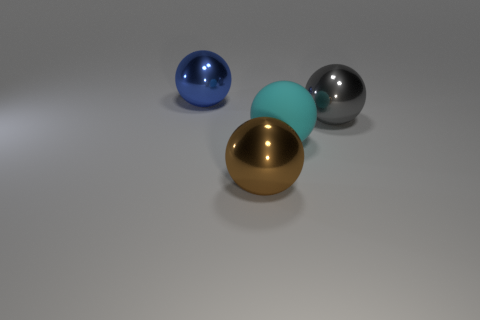What number of things are there?
Your answer should be compact. 4. What is the shape of the metallic object that is to the right of the big shiny sphere that is in front of the large sphere right of the big matte object?
Your response must be concise. Sphere. Are there fewer big gray metallic objects behind the big gray shiny sphere than large rubber things on the left side of the brown metal object?
Offer a very short reply. No. There is a big thing in front of the cyan ball; is its shape the same as the big shiny thing that is on the right side of the matte object?
Ensure brevity in your answer.  Yes. Is there a large purple thing made of the same material as the gray thing?
Make the answer very short. No. What material is the sphere to the left of the brown shiny sphere?
Your answer should be compact. Metal. What material is the gray thing?
Offer a terse response. Metal. Are the large object that is behind the big gray metal sphere and the gray object made of the same material?
Offer a terse response. Yes. Are there fewer large things left of the large blue sphere than blue shiny objects?
Your answer should be compact. Yes. What color is the rubber sphere that is the same size as the gray metal ball?
Provide a succinct answer. Cyan. 